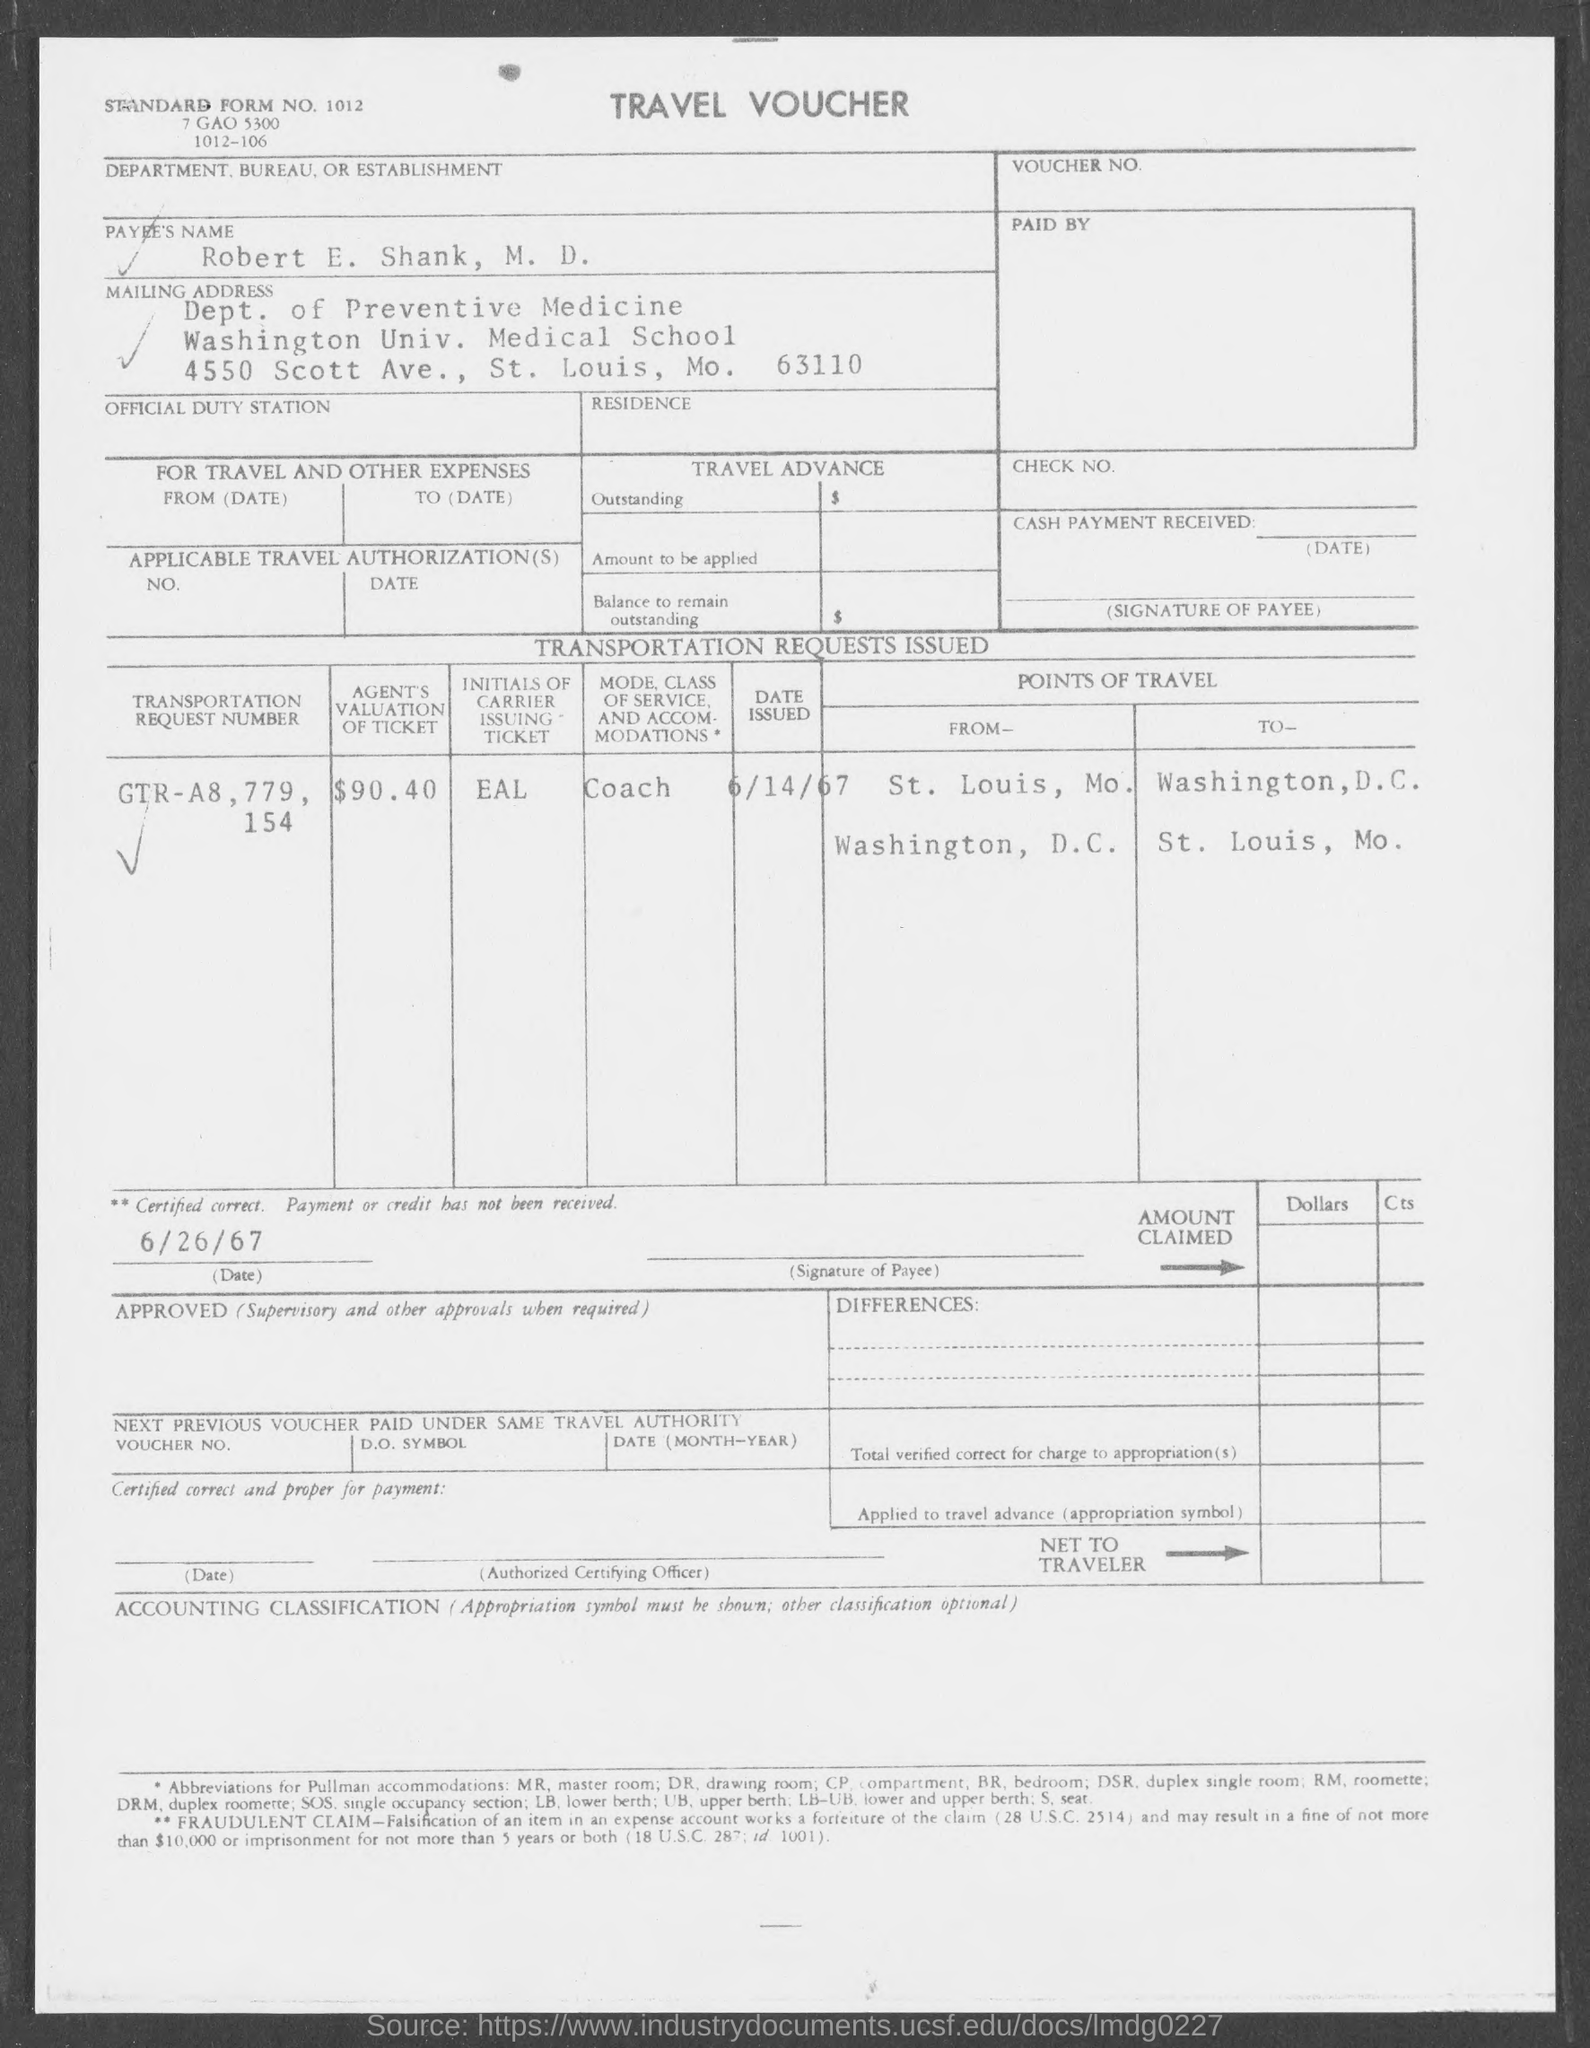What is the standard form no.?
Give a very brief answer. 1012. In which city is washington univ. medical school at ?
Offer a very short reply. St. Louis. 